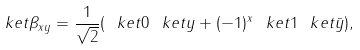<formula> <loc_0><loc_0><loc_500><loc_500>\ k e t { \beta _ { x y } } = \frac { 1 } { \sqrt { 2 } } ( \ k e t { 0 } \ k e t { y } + ( - 1 ) ^ { x } \ k e t { 1 } \ k e t { \bar { y } } ) ,</formula> 